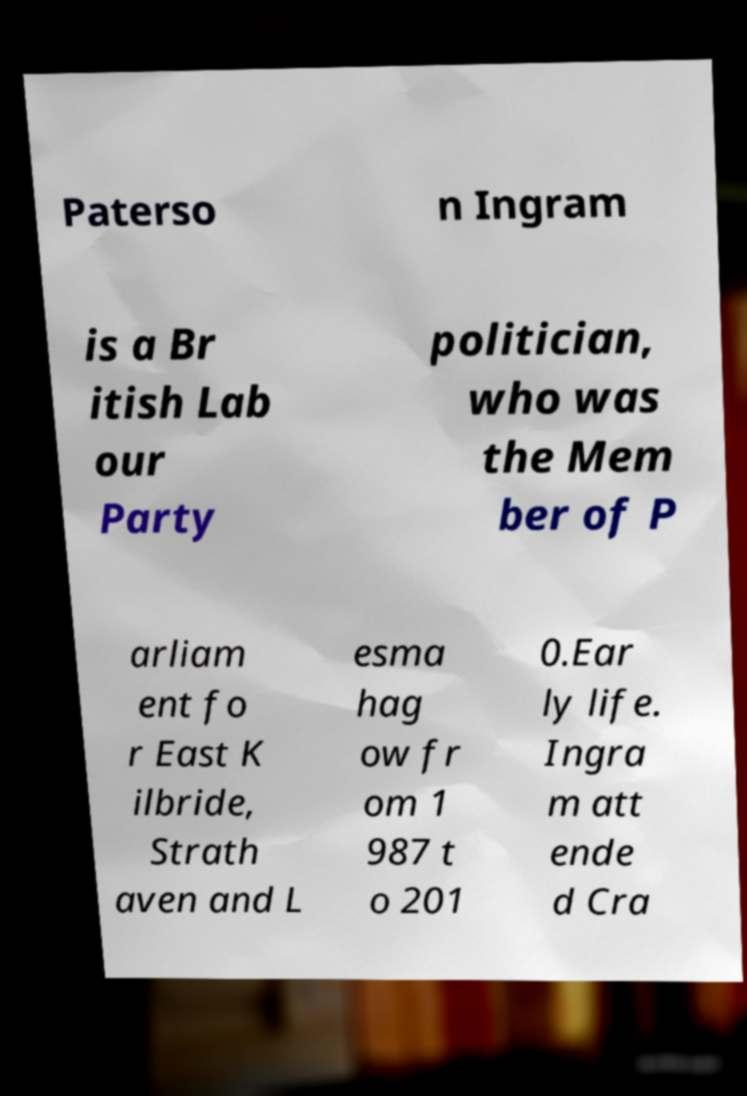Please read and relay the text visible in this image. What does it say? Paterso n Ingram is a Br itish Lab our Party politician, who was the Mem ber of P arliam ent fo r East K ilbride, Strath aven and L esma hag ow fr om 1 987 t o 201 0.Ear ly life. Ingra m att ende d Cra 